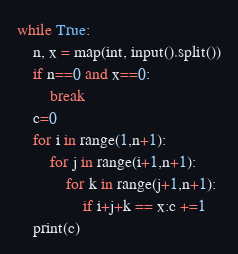<code> <loc_0><loc_0><loc_500><loc_500><_Python_>while True:
    n, x = map(int, input().split())
    if n==0 and x==0:
        break
    c=0
    for i in range(1,n+1):
        for j in range(i+1,n+1):
            for k in range(j+1,n+1):
                if i+j+k == x:c +=1
    print(c)
</code> 